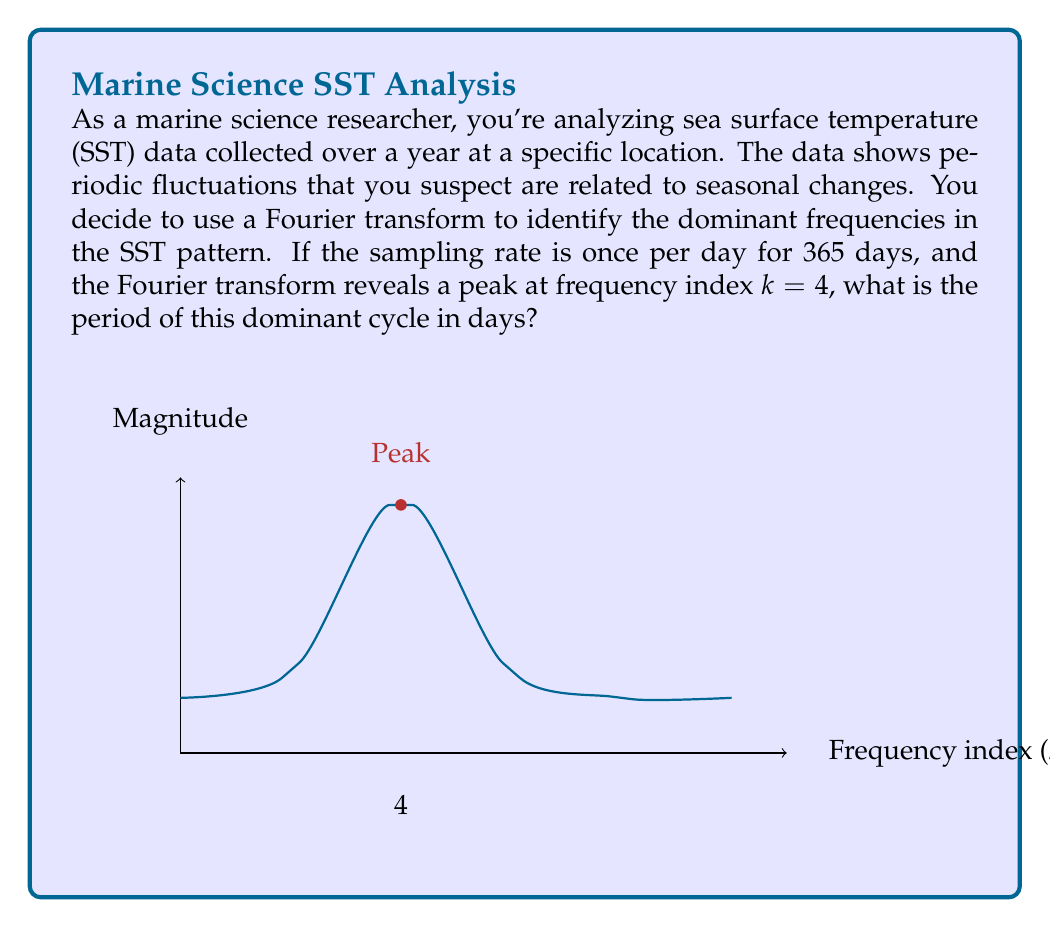Help me with this question. To solve this problem, we need to understand the relationship between the Fourier transform, sampling rate, and signal period. Let's break it down step-by-step:

1) First, recall the fundamental relationship between frequency (f) and period (T):

   $$ T = \frac{1}{f} $$

2) In the discrete Fourier transform (DFT), the frequency associated with each index k is given by:

   $$ f_k = \frac{k}{N\Delta t} $$

   Where N is the total number of samples and Δt is the time between samples.

3) In this case:
   - N = 365 (number of days in a year)
   - Δt = 1 day (sampling once per day)
   - k = 4 (the index of the peak in the Fourier transform)

4) Substituting these values:

   $$ f_4 = \frac{4}{365 \cdot 1} = \frac{4}{365} \text{ cycles/day} $$

5) Now, to find the period, we use the relationship from step 1:

   $$ T = \frac{1}{f_4} = \frac{365}{4} = 91.25 \text{ days} $$

This period corresponds to approximately one season, which aligns with the initial suspicion of seasonal changes in the SST pattern.
Answer: 91.25 days 